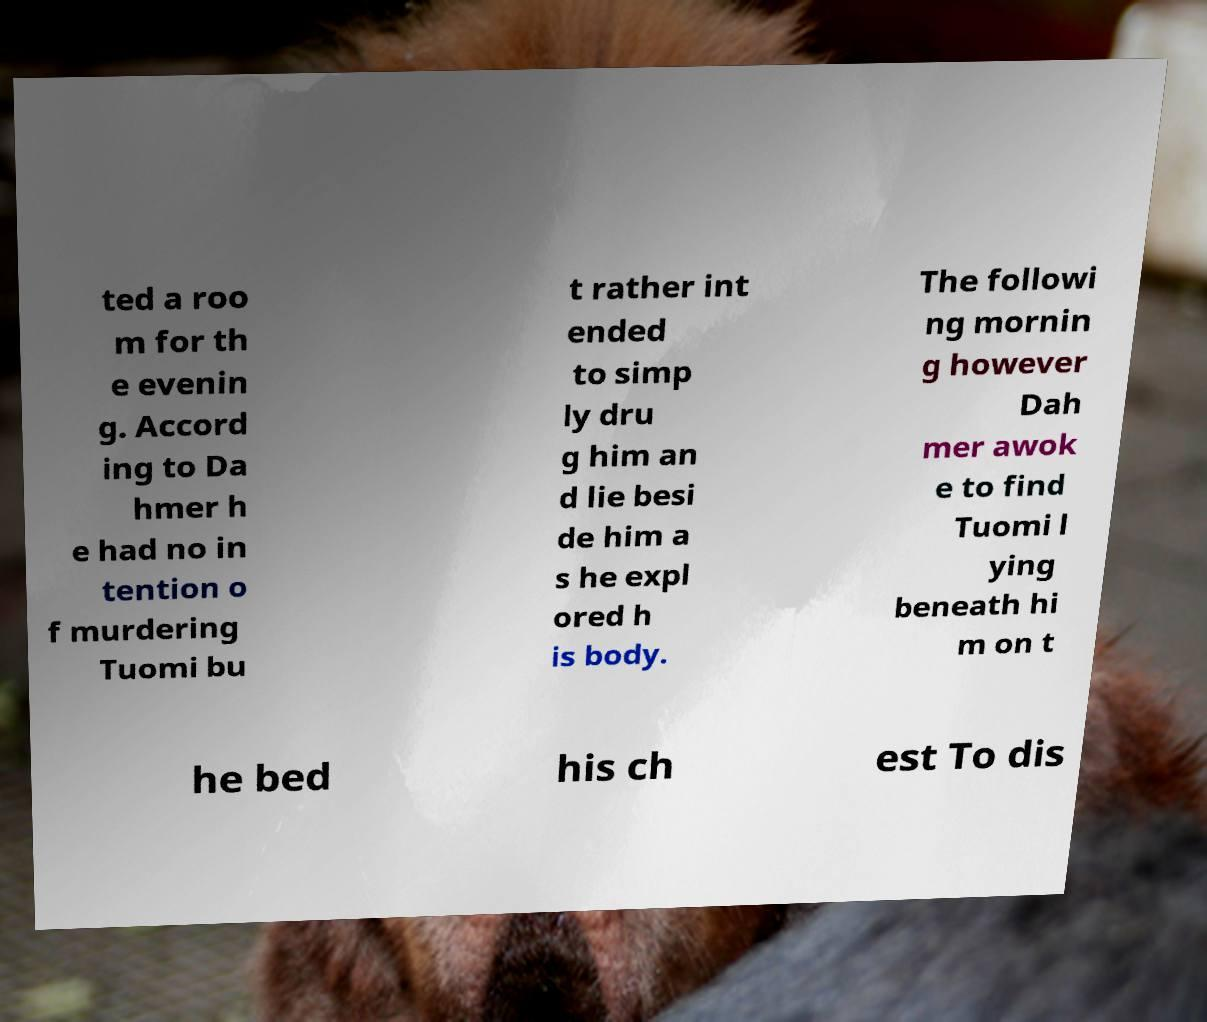Can you accurately transcribe the text from the provided image for me? ted a roo m for th e evenin g. Accord ing to Da hmer h e had no in tention o f murdering Tuomi bu t rather int ended to simp ly dru g him an d lie besi de him a s he expl ored h is body. The followi ng mornin g however Dah mer awok e to find Tuomi l ying beneath hi m on t he bed his ch est To dis 